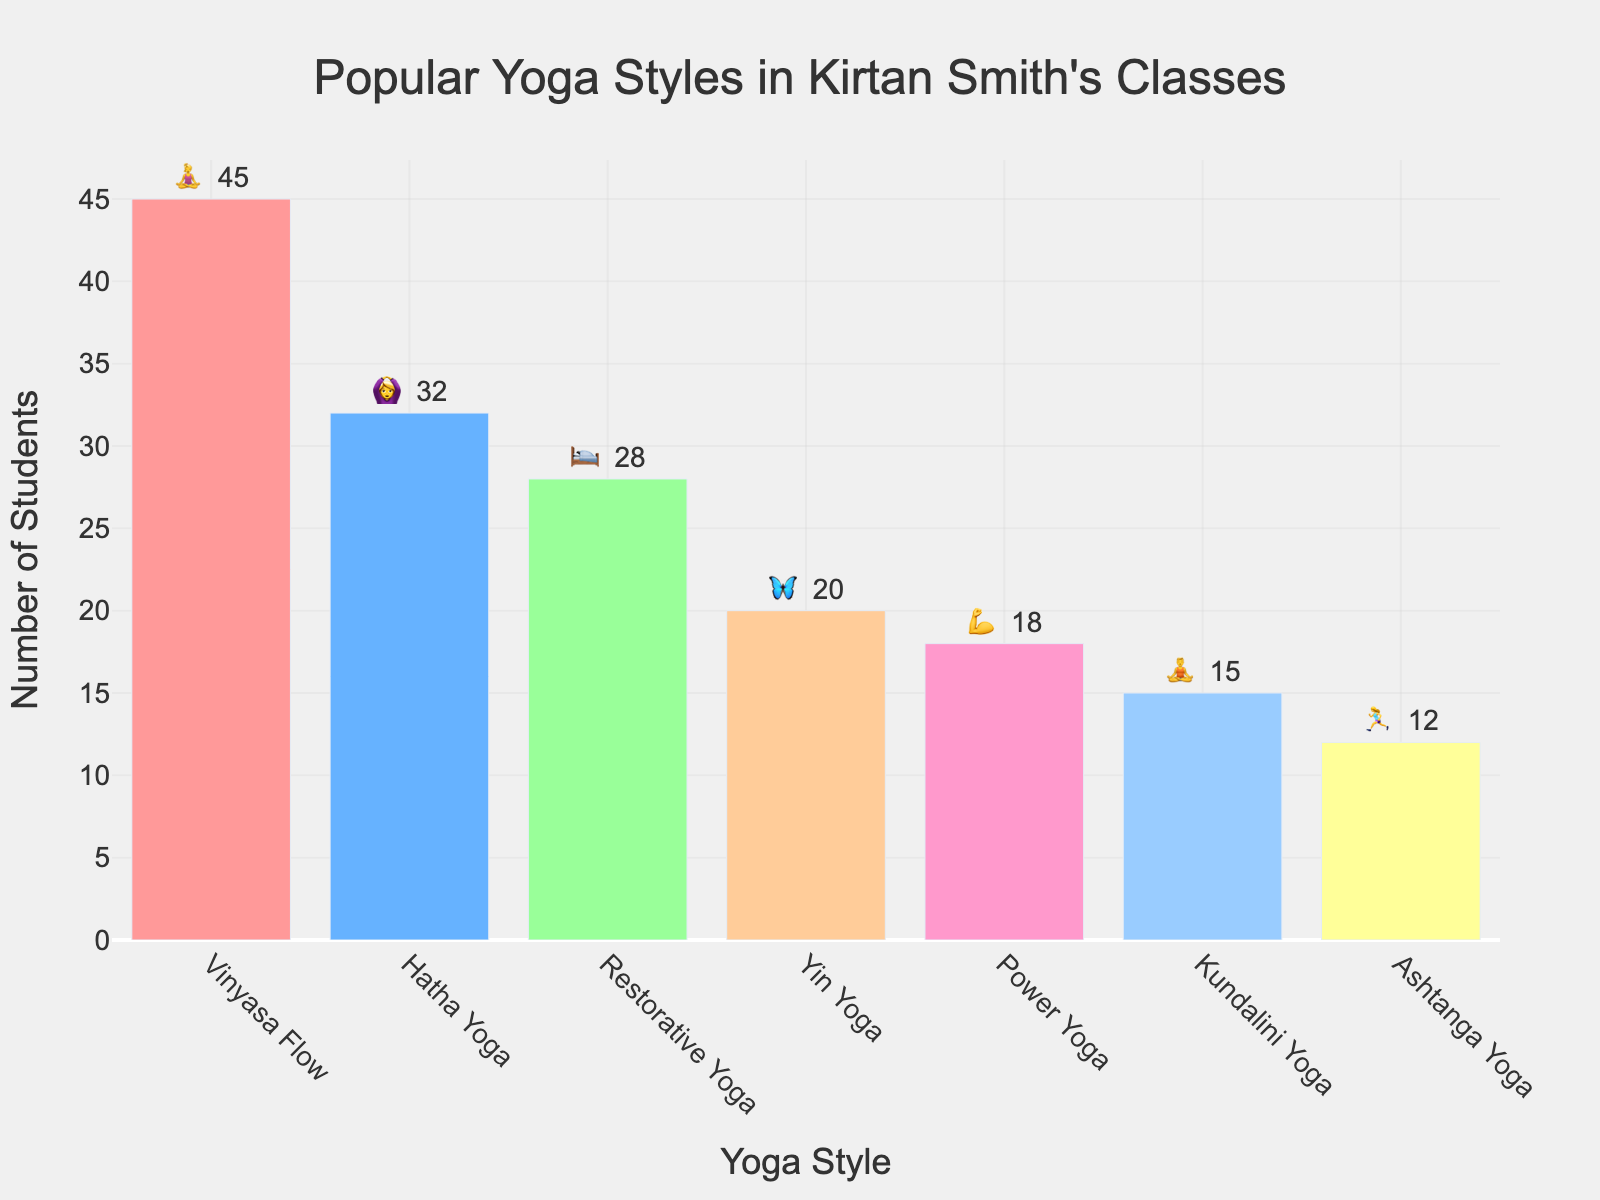What yoga style has the most students? Look for the yoga style with the highest bar on the chart. Vinyasa Flow has the highest bar.
Answer: Vinyasa Flow What yoga style has the fewest students? Identify the shortest bar on the chart. Ashtanga Yoga has the shortest bar.
Answer: Ashtanga Yoga How many students practice Hatha Yoga and Restorative Yoga combined? Sum the students for Hatha Yoga and Restorative Yoga, which are 32 and 28 respectively. 32 + 28 = 60
Answer: 60 What is the difference in the number of students between Vinyasa Flow and Power Yoga? Subtract the number of Power Yoga students (18) from Vinyasa Flow students (45). 45 - 18 = 27
Answer: 27 Which yoga styles have more than 30 students? Check the bars taller than 30. Vinyasa Flow and Hatha Yoga have bars taller than 30.
Answer: Vinyasa Flow, Hatha Yoga Which yoga style has the 💪 emoji? Look at the text above the bars that have the emojis and identify the corresponding yoga style for 💪. Power Yoga
Answer: Power Yoga What fraction of students practice Kundalini Yoga out of those practicing Yin Yoga? Kundalini Yoga has 15 students and Yin Yoga has 20 students. To find the fraction, divide 15 by 20 which simplifies to 3/4 or 0.75.
Answer: 0.75 How many students practice either Yin Yoga or Ashtanga Yoga? Add the number of students practicing Yin Yoga (20) and Ashtanga Yoga (12). 20 + 12 = 32
Answer: 32 How many more students practice Restorative Yoga compared to Yin Yoga? Subtract the number of students practicing Yin Yoga (20) from those practicing Restorative Yoga (28). 28 - 20 = 8
Answer: 8 What yoga style is represented by the emoji 🛌? Look for the bar with the emoji 🛌. Restorative Yoga is represented by 🛌.
Answer: Restorative Yoga 